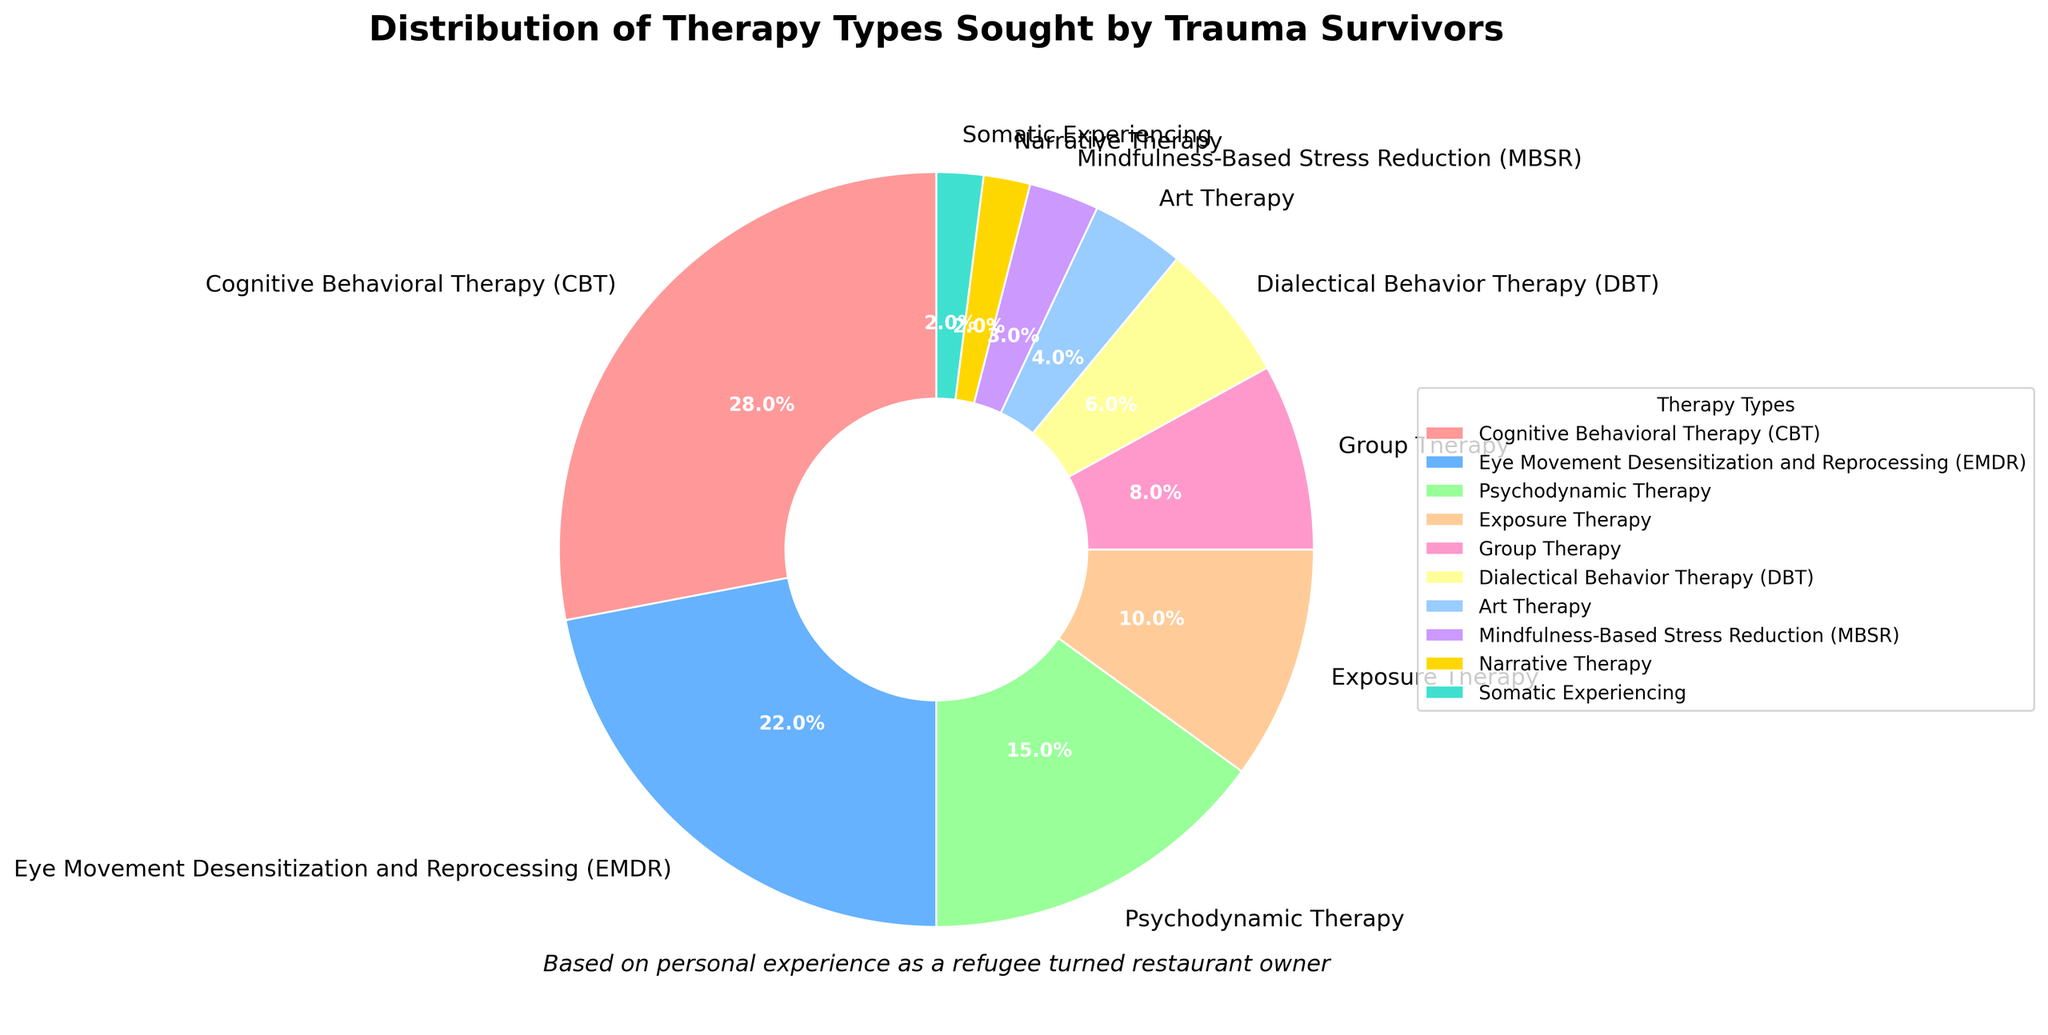What percentage of trauma survivors seek Cognitive Behavioral Therapy (CBT)? The pie chart clearly labels each therapy type along with its percentage. Locate the label "Cognitive Behavioral Therapy (CBT)" and refer to the provided percentage.
Answer: 28% Which is more frequently sought after, Eye Movement Desensitization and Reprocessing (EMDR) or Exposure Therapy? Examine the pie chart for the labels "Eye Movement Desensitization and Reprocessing (EMDR)" and "Exposure Therapy." Compare their respective percentages. EMDR is 22% and Exposure Therapy is 10%; hence, EMDR is more frequently sought after.
Answer: Eye Movement Desensitization and Reprocessing (EMDR) What is the combined percentage of survivors seeking Dialectical Behavior Therapy (DBT) and Art Therapy? Locate the percentages for "Dialectical Behavior Therapy (DBT)" and "Art Therapy" in the pie chart. Sum them up: DBT is 6% and Art Therapy is 4%; thus, the combined percentage is 6% + 4%.
Answer: 10% How does the percentage for Psychodynamic Therapy compare to that of Group Therapy? Identify the percentages for "Psychodynamic Therapy" and "Group Therapy." Psychodynamic Therapy has 15%, while Group Therapy has 8%. Therefore, Psychodynamic Therapy has a higher percentage.
Answer: Psychodynamic Therapy is higher Which therapy type has the smallest percentage of trauma survivors seeking it, and what is that percentage? Refer to the pie chart for the smallest percentage. Both "Narrative Therapy" and "Somatic Experiencing" are labeled with the smallest percentage of 2%.
Answer: Narrative Therapy and Somatic Experiencing, 2% Are there more refugees seeking Mindfulness-Based Stress Reduction (MBSR) or Dialectical Behavior Therapy (DBT), and by how much? Examine the pie chart for the percentages of "Mindfulness-Based Stress Reduction (MBSR)" and "Dialectical Behavior Therapy (DBT)." MBSR has 3% and DBT has 6%. The difference is 6% - 3% = 3%.
Answer: Dialectical Behavior Therapy (DBT) by 3% Which therapy type has a percentage closest to 5%? Check the pie chart for any therapy type with a percentage around 5%. "Art Therapy" stands out with 4%, which is closest to 5%.
Answer: Art Therapy What is the total percentage for all therapy types listed? Sum up all the percentages from the pie chart: 28% + 22% + 15% + 10% + 8% + 6% + 4% + 3% + 2% + 2%. The total is 100%.
Answer: 100% How many therapy types have percentages greater than or equal to 10%? Identify and count the therapy types in the pie chart with percentages of 10% or more: CBT (28%), EMDR (22%), Psychodynamic Therapy (15%), and Exposure Therapy (10%). The count is four.
Answer: 4 